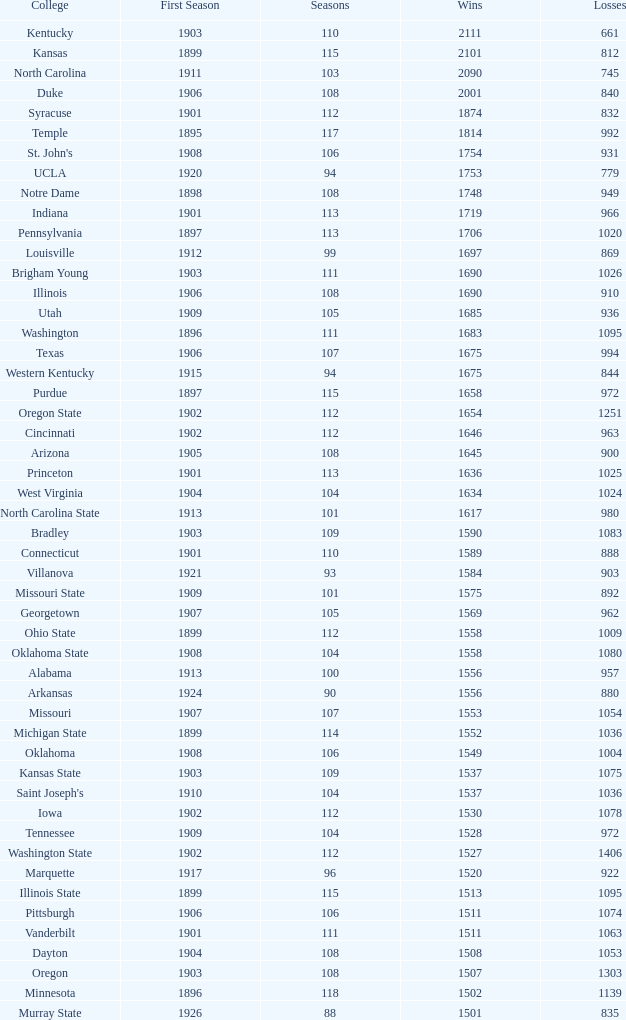What is the overall count of first season games that have 1537 wins and a season surpassing 109? None. Give me the full table as a dictionary. {'header': ['College', 'First Season', 'Seasons', 'Wins', 'Losses'], 'rows': [['Kentucky', '1903', '110', '2111', '661'], ['Kansas', '1899', '115', '2101', '812'], ['North Carolina', '1911', '103', '2090', '745'], ['Duke', '1906', '108', '2001', '840'], ['Syracuse', '1901', '112', '1874', '832'], ['Temple', '1895', '117', '1814', '992'], ["St. John's", '1908', '106', '1754', '931'], ['UCLA', '1920', '94', '1753', '779'], ['Notre Dame', '1898', '108', '1748', '949'], ['Indiana', '1901', '113', '1719', '966'], ['Pennsylvania', '1897', '113', '1706', '1020'], ['Louisville', '1912', '99', '1697', '869'], ['Brigham Young', '1903', '111', '1690', '1026'], ['Illinois', '1906', '108', '1690', '910'], ['Utah', '1909', '105', '1685', '936'], ['Washington', '1896', '111', '1683', '1095'], ['Texas', '1906', '107', '1675', '994'], ['Western Kentucky', '1915', '94', '1675', '844'], ['Purdue', '1897', '115', '1658', '972'], ['Oregon State', '1902', '112', '1654', '1251'], ['Cincinnati', '1902', '112', '1646', '963'], ['Arizona', '1905', '108', '1645', '900'], ['Princeton', '1901', '113', '1636', '1025'], ['West Virginia', '1904', '104', '1634', '1024'], ['North Carolina State', '1913', '101', '1617', '980'], ['Bradley', '1903', '109', '1590', '1083'], ['Connecticut', '1901', '110', '1589', '888'], ['Villanova', '1921', '93', '1584', '903'], ['Missouri State', '1909', '101', '1575', '892'], ['Georgetown', '1907', '105', '1569', '962'], ['Ohio State', '1899', '112', '1558', '1009'], ['Oklahoma State', '1908', '104', '1558', '1080'], ['Alabama', '1913', '100', '1556', '957'], ['Arkansas', '1924', '90', '1556', '880'], ['Missouri', '1907', '107', '1553', '1054'], ['Michigan State', '1899', '114', '1552', '1036'], ['Oklahoma', '1908', '106', '1549', '1004'], ['Kansas State', '1903', '109', '1537', '1075'], ["Saint Joseph's", '1910', '104', '1537', '1036'], ['Iowa', '1902', '112', '1530', '1078'], ['Tennessee', '1909', '104', '1528', '972'], ['Washington State', '1902', '112', '1527', '1406'], ['Marquette', '1917', '96', '1520', '922'], ['Illinois State', '1899', '115', '1513', '1095'], ['Pittsburgh', '1906', '106', '1511', '1074'], ['Vanderbilt', '1901', '111', '1511', '1063'], ['Dayton', '1904', '108', '1508', '1053'], ['Oregon', '1903', '108', '1507', '1303'], ['Minnesota', '1896', '118', '1502', '1139'], ['Murray State', '1926', '88', '1501', '835']]} 